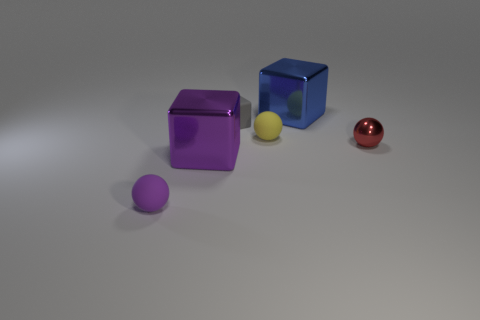Subtract all tiny metallic balls. How many balls are left? 2 Add 2 purple objects. How many objects exist? 8 Subtract all green balls. Subtract all blue cubes. How many balls are left? 3 Add 2 large red objects. How many large red objects exist? 2 Subtract 1 gray blocks. How many objects are left? 5 Subtract all tiny red things. Subtract all matte balls. How many objects are left? 3 Add 6 tiny red metal balls. How many tiny red metal balls are left? 7 